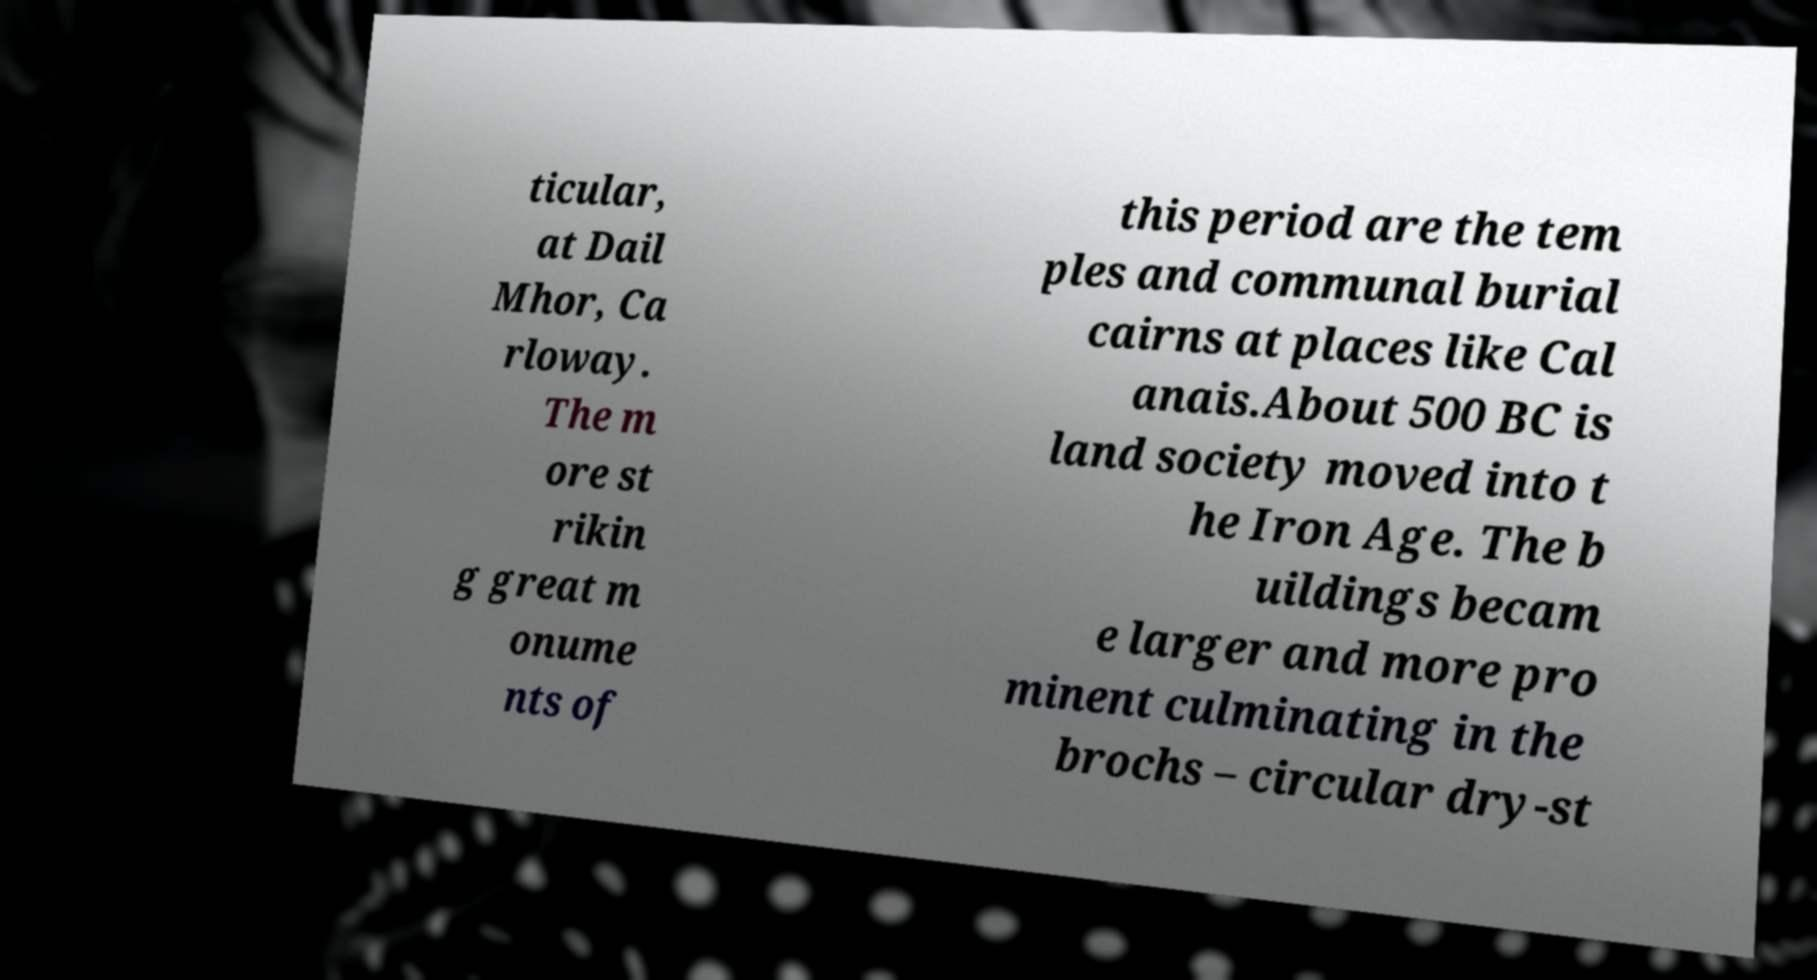Please identify and transcribe the text found in this image. ticular, at Dail Mhor, Ca rloway. The m ore st rikin g great m onume nts of this period are the tem ples and communal burial cairns at places like Cal anais.About 500 BC is land society moved into t he Iron Age. The b uildings becam e larger and more pro minent culminating in the brochs – circular dry-st 